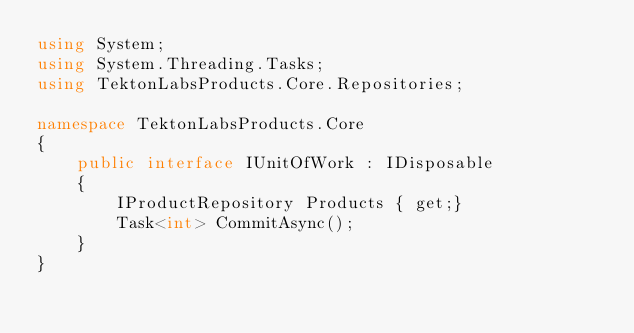Convert code to text. <code><loc_0><loc_0><loc_500><loc_500><_C#_>using System;
using System.Threading.Tasks;
using TektonLabsProducts.Core.Repositories;

namespace TektonLabsProducts.Core
{
    public interface IUnitOfWork : IDisposable
    {
        IProductRepository Products { get;}
        Task<int> CommitAsync();
    }
}</code> 